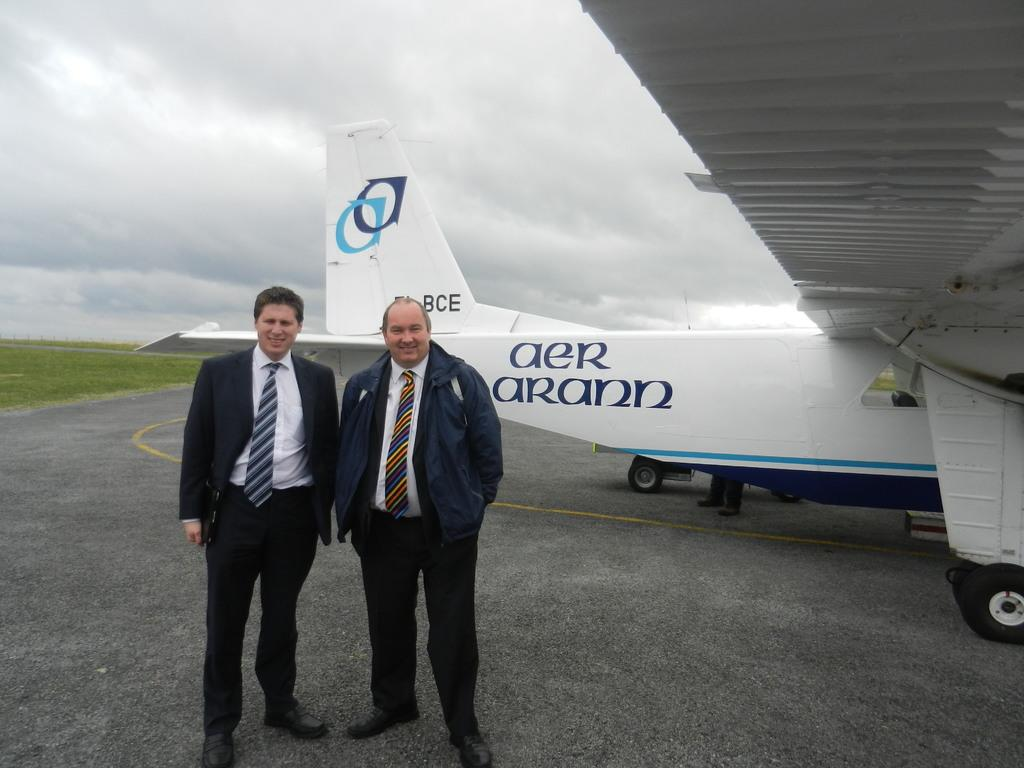<image>
Write a terse but informative summary of the picture. Two men stand in front of an airplane that has the words "aer arann" painted onto the side of it. 